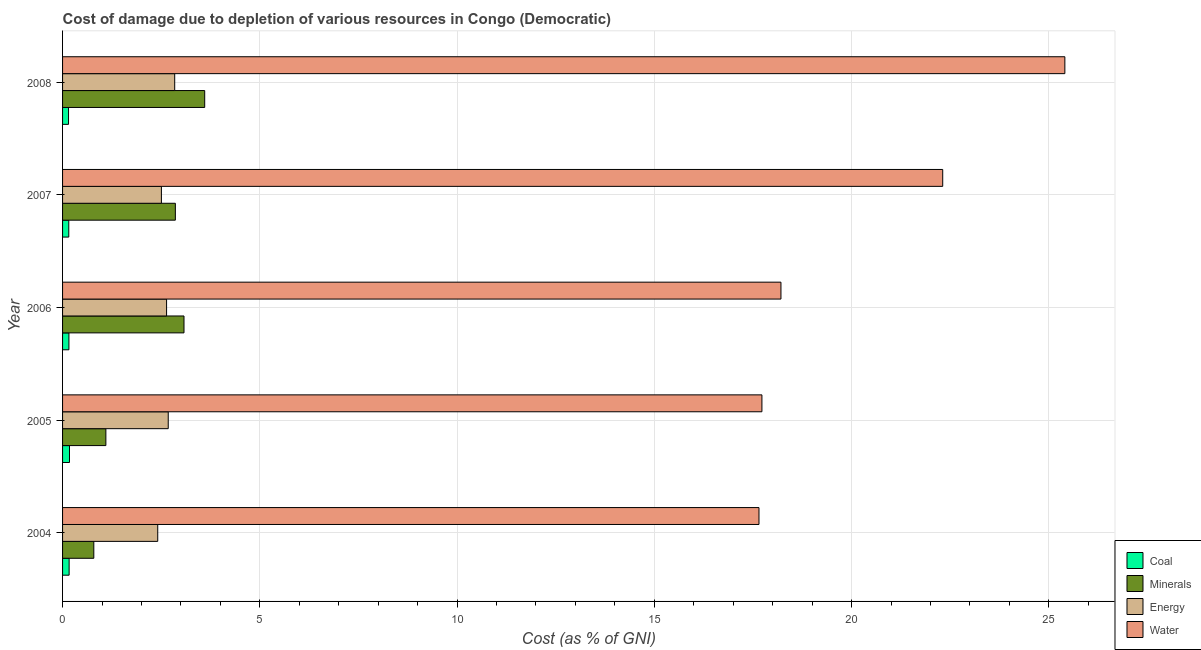Are the number of bars per tick equal to the number of legend labels?
Provide a short and direct response. Yes. How many bars are there on the 1st tick from the bottom?
Provide a short and direct response. 4. What is the cost of damage due to depletion of energy in 2006?
Make the answer very short. 2.64. Across all years, what is the maximum cost of damage due to depletion of water?
Your answer should be compact. 25.41. Across all years, what is the minimum cost of damage due to depletion of energy?
Your answer should be very brief. 2.41. In which year was the cost of damage due to depletion of water minimum?
Make the answer very short. 2004. What is the total cost of damage due to depletion of energy in the graph?
Your response must be concise. 13.08. What is the difference between the cost of damage due to depletion of energy in 2005 and that in 2007?
Give a very brief answer. 0.17. What is the difference between the cost of damage due to depletion of minerals in 2004 and the cost of damage due to depletion of coal in 2006?
Provide a short and direct response. 0.63. What is the average cost of damage due to depletion of coal per year?
Offer a very short reply. 0.16. In the year 2007, what is the difference between the cost of damage due to depletion of energy and cost of damage due to depletion of coal?
Provide a short and direct response. 2.35. In how many years, is the cost of damage due to depletion of minerals greater than 1 %?
Offer a terse response. 4. What is the ratio of the cost of damage due to depletion of energy in 2006 to that in 2008?
Ensure brevity in your answer.  0.93. Is the cost of damage due to depletion of minerals in 2006 less than that in 2008?
Offer a terse response. Yes. What is the difference between the highest and the second highest cost of damage due to depletion of minerals?
Your answer should be compact. 0.53. What is the difference between the highest and the lowest cost of damage due to depletion of coal?
Keep it short and to the point. 0.02. Is the sum of the cost of damage due to depletion of energy in 2005 and 2007 greater than the maximum cost of damage due to depletion of minerals across all years?
Offer a very short reply. Yes. Is it the case that in every year, the sum of the cost of damage due to depletion of water and cost of damage due to depletion of energy is greater than the sum of cost of damage due to depletion of minerals and cost of damage due to depletion of coal?
Your answer should be compact. Yes. What does the 1st bar from the top in 2004 represents?
Provide a short and direct response. Water. What does the 1st bar from the bottom in 2008 represents?
Offer a very short reply. Coal. Is it the case that in every year, the sum of the cost of damage due to depletion of coal and cost of damage due to depletion of minerals is greater than the cost of damage due to depletion of energy?
Offer a very short reply. No. Does the graph contain any zero values?
Keep it short and to the point. No. How many legend labels are there?
Provide a succinct answer. 4. What is the title of the graph?
Your response must be concise. Cost of damage due to depletion of various resources in Congo (Democratic) . What is the label or title of the X-axis?
Give a very brief answer. Cost (as % of GNI). What is the Cost (as % of GNI) in Coal in 2004?
Provide a succinct answer. 0.17. What is the Cost (as % of GNI) of Minerals in 2004?
Your response must be concise. 0.79. What is the Cost (as % of GNI) of Energy in 2004?
Provide a short and direct response. 2.41. What is the Cost (as % of GNI) of Water in 2004?
Offer a very short reply. 17.65. What is the Cost (as % of GNI) in Coal in 2005?
Ensure brevity in your answer.  0.18. What is the Cost (as % of GNI) of Minerals in 2005?
Provide a succinct answer. 1.1. What is the Cost (as % of GNI) of Energy in 2005?
Make the answer very short. 2.68. What is the Cost (as % of GNI) in Water in 2005?
Keep it short and to the point. 17.73. What is the Cost (as % of GNI) in Coal in 2006?
Ensure brevity in your answer.  0.16. What is the Cost (as % of GNI) in Minerals in 2006?
Your response must be concise. 3.08. What is the Cost (as % of GNI) in Energy in 2006?
Your answer should be very brief. 2.64. What is the Cost (as % of GNI) of Water in 2006?
Offer a very short reply. 18.21. What is the Cost (as % of GNI) in Coal in 2007?
Your response must be concise. 0.16. What is the Cost (as % of GNI) in Minerals in 2007?
Offer a terse response. 2.86. What is the Cost (as % of GNI) in Energy in 2007?
Offer a very short reply. 2.51. What is the Cost (as % of GNI) in Water in 2007?
Provide a succinct answer. 22.31. What is the Cost (as % of GNI) in Coal in 2008?
Offer a very short reply. 0.15. What is the Cost (as % of GNI) in Minerals in 2008?
Your answer should be very brief. 3.6. What is the Cost (as % of GNI) of Energy in 2008?
Your answer should be very brief. 2.84. What is the Cost (as % of GNI) in Water in 2008?
Ensure brevity in your answer.  25.41. Across all years, what is the maximum Cost (as % of GNI) in Coal?
Give a very brief answer. 0.18. Across all years, what is the maximum Cost (as % of GNI) of Minerals?
Provide a short and direct response. 3.6. Across all years, what is the maximum Cost (as % of GNI) of Energy?
Ensure brevity in your answer.  2.84. Across all years, what is the maximum Cost (as % of GNI) of Water?
Offer a very short reply. 25.41. Across all years, what is the minimum Cost (as % of GNI) in Coal?
Keep it short and to the point. 0.15. Across all years, what is the minimum Cost (as % of GNI) of Minerals?
Make the answer very short. 0.79. Across all years, what is the minimum Cost (as % of GNI) of Energy?
Keep it short and to the point. 2.41. Across all years, what is the minimum Cost (as % of GNI) of Water?
Keep it short and to the point. 17.65. What is the total Cost (as % of GNI) of Coal in the graph?
Offer a very short reply. 0.81. What is the total Cost (as % of GNI) of Minerals in the graph?
Provide a short and direct response. 11.43. What is the total Cost (as % of GNI) of Energy in the graph?
Your response must be concise. 13.08. What is the total Cost (as % of GNI) in Water in the graph?
Give a very brief answer. 101.31. What is the difference between the Cost (as % of GNI) in Coal in 2004 and that in 2005?
Your answer should be very brief. -0.01. What is the difference between the Cost (as % of GNI) of Minerals in 2004 and that in 2005?
Your answer should be compact. -0.31. What is the difference between the Cost (as % of GNI) of Energy in 2004 and that in 2005?
Keep it short and to the point. -0.27. What is the difference between the Cost (as % of GNI) in Water in 2004 and that in 2005?
Offer a terse response. -0.07. What is the difference between the Cost (as % of GNI) of Coal in 2004 and that in 2006?
Offer a very short reply. 0.01. What is the difference between the Cost (as % of GNI) in Minerals in 2004 and that in 2006?
Provide a succinct answer. -2.29. What is the difference between the Cost (as % of GNI) in Energy in 2004 and that in 2006?
Provide a succinct answer. -0.22. What is the difference between the Cost (as % of GNI) in Water in 2004 and that in 2006?
Your answer should be very brief. -0.56. What is the difference between the Cost (as % of GNI) of Coal in 2004 and that in 2007?
Give a very brief answer. 0.01. What is the difference between the Cost (as % of GNI) of Minerals in 2004 and that in 2007?
Make the answer very short. -2.07. What is the difference between the Cost (as % of GNI) in Energy in 2004 and that in 2007?
Ensure brevity in your answer.  -0.09. What is the difference between the Cost (as % of GNI) of Water in 2004 and that in 2007?
Ensure brevity in your answer.  -4.66. What is the difference between the Cost (as % of GNI) of Coal in 2004 and that in 2008?
Your answer should be very brief. 0.02. What is the difference between the Cost (as % of GNI) of Minerals in 2004 and that in 2008?
Provide a succinct answer. -2.81. What is the difference between the Cost (as % of GNI) of Energy in 2004 and that in 2008?
Provide a short and direct response. -0.43. What is the difference between the Cost (as % of GNI) of Water in 2004 and that in 2008?
Keep it short and to the point. -7.75. What is the difference between the Cost (as % of GNI) of Coal in 2005 and that in 2006?
Provide a succinct answer. 0.01. What is the difference between the Cost (as % of GNI) in Minerals in 2005 and that in 2006?
Offer a terse response. -1.98. What is the difference between the Cost (as % of GNI) in Energy in 2005 and that in 2006?
Ensure brevity in your answer.  0.04. What is the difference between the Cost (as % of GNI) in Water in 2005 and that in 2006?
Offer a very short reply. -0.48. What is the difference between the Cost (as % of GNI) in Coal in 2005 and that in 2007?
Offer a very short reply. 0.02. What is the difference between the Cost (as % of GNI) in Minerals in 2005 and that in 2007?
Your answer should be compact. -1.76. What is the difference between the Cost (as % of GNI) in Energy in 2005 and that in 2007?
Provide a succinct answer. 0.17. What is the difference between the Cost (as % of GNI) of Water in 2005 and that in 2007?
Offer a very short reply. -4.58. What is the difference between the Cost (as % of GNI) in Coal in 2005 and that in 2008?
Provide a short and direct response. 0.02. What is the difference between the Cost (as % of GNI) of Minerals in 2005 and that in 2008?
Your answer should be very brief. -2.51. What is the difference between the Cost (as % of GNI) of Energy in 2005 and that in 2008?
Your answer should be very brief. -0.16. What is the difference between the Cost (as % of GNI) of Water in 2005 and that in 2008?
Provide a short and direct response. -7.68. What is the difference between the Cost (as % of GNI) of Coal in 2006 and that in 2007?
Provide a short and direct response. 0. What is the difference between the Cost (as % of GNI) of Minerals in 2006 and that in 2007?
Your answer should be very brief. 0.22. What is the difference between the Cost (as % of GNI) of Energy in 2006 and that in 2007?
Provide a succinct answer. 0.13. What is the difference between the Cost (as % of GNI) in Water in 2006 and that in 2007?
Keep it short and to the point. -4.1. What is the difference between the Cost (as % of GNI) of Coal in 2006 and that in 2008?
Your response must be concise. 0.01. What is the difference between the Cost (as % of GNI) in Minerals in 2006 and that in 2008?
Offer a terse response. -0.53. What is the difference between the Cost (as % of GNI) of Energy in 2006 and that in 2008?
Your response must be concise. -0.21. What is the difference between the Cost (as % of GNI) in Water in 2006 and that in 2008?
Offer a very short reply. -7.2. What is the difference between the Cost (as % of GNI) in Coal in 2007 and that in 2008?
Offer a very short reply. 0.01. What is the difference between the Cost (as % of GNI) in Minerals in 2007 and that in 2008?
Ensure brevity in your answer.  -0.74. What is the difference between the Cost (as % of GNI) of Energy in 2007 and that in 2008?
Ensure brevity in your answer.  -0.34. What is the difference between the Cost (as % of GNI) of Water in 2007 and that in 2008?
Your answer should be compact. -3.1. What is the difference between the Cost (as % of GNI) in Coal in 2004 and the Cost (as % of GNI) in Minerals in 2005?
Make the answer very short. -0.93. What is the difference between the Cost (as % of GNI) of Coal in 2004 and the Cost (as % of GNI) of Energy in 2005?
Provide a succinct answer. -2.51. What is the difference between the Cost (as % of GNI) of Coal in 2004 and the Cost (as % of GNI) of Water in 2005?
Offer a terse response. -17.56. What is the difference between the Cost (as % of GNI) of Minerals in 2004 and the Cost (as % of GNI) of Energy in 2005?
Make the answer very short. -1.89. What is the difference between the Cost (as % of GNI) in Minerals in 2004 and the Cost (as % of GNI) in Water in 2005?
Offer a terse response. -16.94. What is the difference between the Cost (as % of GNI) in Energy in 2004 and the Cost (as % of GNI) in Water in 2005?
Your answer should be compact. -15.32. What is the difference between the Cost (as % of GNI) in Coal in 2004 and the Cost (as % of GNI) in Minerals in 2006?
Provide a succinct answer. -2.91. What is the difference between the Cost (as % of GNI) in Coal in 2004 and the Cost (as % of GNI) in Energy in 2006?
Provide a succinct answer. -2.47. What is the difference between the Cost (as % of GNI) of Coal in 2004 and the Cost (as % of GNI) of Water in 2006?
Your response must be concise. -18.04. What is the difference between the Cost (as % of GNI) in Minerals in 2004 and the Cost (as % of GNI) in Energy in 2006?
Your answer should be compact. -1.84. What is the difference between the Cost (as % of GNI) of Minerals in 2004 and the Cost (as % of GNI) of Water in 2006?
Your answer should be compact. -17.42. What is the difference between the Cost (as % of GNI) of Energy in 2004 and the Cost (as % of GNI) of Water in 2006?
Offer a very short reply. -15.8. What is the difference between the Cost (as % of GNI) of Coal in 2004 and the Cost (as % of GNI) of Minerals in 2007?
Ensure brevity in your answer.  -2.69. What is the difference between the Cost (as % of GNI) in Coal in 2004 and the Cost (as % of GNI) in Energy in 2007?
Offer a terse response. -2.34. What is the difference between the Cost (as % of GNI) in Coal in 2004 and the Cost (as % of GNI) in Water in 2007?
Give a very brief answer. -22.14. What is the difference between the Cost (as % of GNI) in Minerals in 2004 and the Cost (as % of GNI) in Energy in 2007?
Ensure brevity in your answer.  -1.71. What is the difference between the Cost (as % of GNI) of Minerals in 2004 and the Cost (as % of GNI) of Water in 2007?
Ensure brevity in your answer.  -21.52. What is the difference between the Cost (as % of GNI) of Energy in 2004 and the Cost (as % of GNI) of Water in 2007?
Your response must be concise. -19.9. What is the difference between the Cost (as % of GNI) in Coal in 2004 and the Cost (as % of GNI) in Minerals in 2008?
Offer a very short reply. -3.44. What is the difference between the Cost (as % of GNI) in Coal in 2004 and the Cost (as % of GNI) in Energy in 2008?
Your answer should be compact. -2.68. What is the difference between the Cost (as % of GNI) in Coal in 2004 and the Cost (as % of GNI) in Water in 2008?
Keep it short and to the point. -25.24. What is the difference between the Cost (as % of GNI) in Minerals in 2004 and the Cost (as % of GNI) in Energy in 2008?
Ensure brevity in your answer.  -2.05. What is the difference between the Cost (as % of GNI) in Minerals in 2004 and the Cost (as % of GNI) in Water in 2008?
Provide a succinct answer. -24.61. What is the difference between the Cost (as % of GNI) of Energy in 2004 and the Cost (as % of GNI) of Water in 2008?
Offer a terse response. -22.99. What is the difference between the Cost (as % of GNI) in Coal in 2005 and the Cost (as % of GNI) in Minerals in 2006?
Your answer should be very brief. -2.9. What is the difference between the Cost (as % of GNI) of Coal in 2005 and the Cost (as % of GNI) of Energy in 2006?
Provide a succinct answer. -2.46. What is the difference between the Cost (as % of GNI) in Coal in 2005 and the Cost (as % of GNI) in Water in 2006?
Your answer should be very brief. -18.03. What is the difference between the Cost (as % of GNI) in Minerals in 2005 and the Cost (as % of GNI) in Energy in 2006?
Make the answer very short. -1.54. What is the difference between the Cost (as % of GNI) in Minerals in 2005 and the Cost (as % of GNI) in Water in 2006?
Make the answer very short. -17.11. What is the difference between the Cost (as % of GNI) in Energy in 2005 and the Cost (as % of GNI) in Water in 2006?
Provide a short and direct response. -15.53. What is the difference between the Cost (as % of GNI) of Coal in 2005 and the Cost (as % of GNI) of Minerals in 2007?
Give a very brief answer. -2.68. What is the difference between the Cost (as % of GNI) in Coal in 2005 and the Cost (as % of GNI) in Energy in 2007?
Offer a terse response. -2.33. What is the difference between the Cost (as % of GNI) of Coal in 2005 and the Cost (as % of GNI) of Water in 2007?
Provide a short and direct response. -22.13. What is the difference between the Cost (as % of GNI) in Minerals in 2005 and the Cost (as % of GNI) in Energy in 2007?
Your answer should be very brief. -1.41. What is the difference between the Cost (as % of GNI) of Minerals in 2005 and the Cost (as % of GNI) of Water in 2007?
Ensure brevity in your answer.  -21.21. What is the difference between the Cost (as % of GNI) in Energy in 2005 and the Cost (as % of GNI) in Water in 2007?
Offer a very short reply. -19.63. What is the difference between the Cost (as % of GNI) in Coal in 2005 and the Cost (as % of GNI) in Minerals in 2008?
Keep it short and to the point. -3.43. What is the difference between the Cost (as % of GNI) of Coal in 2005 and the Cost (as % of GNI) of Energy in 2008?
Provide a short and direct response. -2.67. What is the difference between the Cost (as % of GNI) of Coal in 2005 and the Cost (as % of GNI) of Water in 2008?
Your response must be concise. -25.23. What is the difference between the Cost (as % of GNI) in Minerals in 2005 and the Cost (as % of GNI) in Energy in 2008?
Provide a short and direct response. -1.74. What is the difference between the Cost (as % of GNI) of Minerals in 2005 and the Cost (as % of GNI) of Water in 2008?
Your answer should be compact. -24.31. What is the difference between the Cost (as % of GNI) of Energy in 2005 and the Cost (as % of GNI) of Water in 2008?
Make the answer very short. -22.73. What is the difference between the Cost (as % of GNI) in Coal in 2006 and the Cost (as % of GNI) in Minerals in 2007?
Keep it short and to the point. -2.7. What is the difference between the Cost (as % of GNI) in Coal in 2006 and the Cost (as % of GNI) in Energy in 2007?
Provide a succinct answer. -2.34. What is the difference between the Cost (as % of GNI) in Coal in 2006 and the Cost (as % of GNI) in Water in 2007?
Give a very brief answer. -22.15. What is the difference between the Cost (as % of GNI) of Minerals in 2006 and the Cost (as % of GNI) of Energy in 2007?
Give a very brief answer. 0.57. What is the difference between the Cost (as % of GNI) of Minerals in 2006 and the Cost (as % of GNI) of Water in 2007?
Your answer should be compact. -19.23. What is the difference between the Cost (as % of GNI) in Energy in 2006 and the Cost (as % of GNI) in Water in 2007?
Your answer should be very brief. -19.67. What is the difference between the Cost (as % of GNI) of Coal in 2006 and the Cost (as % of GNI) of Minerals in 2008?
Make the answer very short. -3.44. What is the difference between the Cost (as % of GNI) in Coal in 2006 and the Cost (as % of GNI) in Energy in 2008?
Your answer should be compact. -2.68. What is the difference between the Cost (as % of GNI) of Coal in 2006 and the Cost (as % of GNI) of Water in 2008?
Provide a succinct answer. -25.25. What is the difference between the Cost (as % of GNI) in Minerals in 2006 and the Cost (as % of GNI) in Energy in 2008?
Keep it short and to the point. 0.24. What is the difference between the Cost (as % of GNI) in Minerals in 2006 and the Cost (as % of GNI) in Water in 2008?
Offer a very short reply. -22.33. What is the difference between the Cost (as % of GNI) in Energy in 2006 and the Cost (as % of GNI) in Water in 2008?
Offer a terse response. -22.77. What is the difference between the Cost (as % of GNI) in Coal in 2007 and the Cost (as % of GNI) in Minerals in 2008?
Provide a succinct answer. -3.45. What is the difference between the Cost (as % of GNI) of Coal in 2007 and the Cost (as % of GNI) of Energy in 2008?
Provide a succinct answer. -2.68. What is the difference between the Cost (as % of GNI) of Coal in 2007 and the Cost (as % of GNI) of Water in 2008?
Ensure brevity in your answer.  -25.25. What is the difference between the Cost (as % of GNI) in Minerals in 2007 and the Cost (as % of GNI) in Energy in 2008?
Your response must be concise. 0.02. What is the difference between the Cost (as % of GNI) of Minerals in 2007 and the Cost (as % of GNI) of Water in 2008?
Ensure brevity in your answer.  -22.55. What is the difference between the Cost (as % of GNI) of Energy in 2007 and the Cost (as % of GNI) of Water in 2008?
Your response must be concise. -22.9. What is the average Cost (as % of GNI) in Coal per year?
Provide a succinct answer. 0.16. What is the average Cost (as % of GNI) of Minerals per year?
Keep it short and to the point. 2.29. What is the average Cost (as % of GNI) of Energy per year?
Keep it short and to the point. 2.62. What is the average Cost (as % of GNI) of Water per year?
Your answer should be very brief. 20.26. In the year 2004, what is the difference between the Cost (as % of GNI) in Coal and Cost (as % of GNI) in Minerals?
Provide a succinct answer. -0.63. In the year 2004, what is the difference between the Cost (as % of GNI) in Coal and Cost (as % of GNI) in Energy?
Give a very brief answer. -2.25. In the year 2004, what is the difference between the Cost (as % of GNI) of Coal and Cost (as % of GNI) of Water?
Your response must be concise. -17.49. In the year 2004, what is the difference between the Cost (as % of GNI) of Minerals and Cost (as % of GNI) of Energy?
Ensure brevity in your answer.  -1.62. In the year 2004, what is the difference between the Cost (as % of GNI) in Minerals and Cost (as % of GNI) in Water?
Ensure brevity in your answer.  -16.86. In the year 2004, what is the difference between the Cost (as % of GNI) of Energy and Cost (as % of GNI) of Water?
Offer a very short reply. -15.24. In the year 2005, what is the difference between the Cost (as % of GNI) of Coal and Cost (as % of GNI) of Minerals?
Your answer should be very brief. -0.92. In the year 2005, what is the difference between the Cost (as % of GNI) of Coal and Cost (as % of GNI) of Energy?
Your response must be concise. -2.5. In the year 2005, what is the difference between the Cost (as % of GNI) in Coal and Cost (as % of GNI) in Water?
Ensure brevity in your answer.  -17.55. In the year 2005, what is the difference between the Cost (as % of GNI) in Minerals and Cost (as % of GNI) in Energy?
Ensure brevity in your answer.  -1.58. In the year 2005, what is the difference between the Cost (as % of GNI) of Minerals and Cost (as % of GNI) of Water?
Make the answer very short. -16.63. In the year 2005, what is the difference between the Cost (as % of GNI) of Energy and Cost (as % of GNI) of Water?
Make the answer very short. -15.05. In the year 2006, what is the difference between the Cost (as % of GNI) of Coal and Cost (as % of GNI) of Minerals?
Your answer should be very brief. -2.92. In the year 2006, what is the difference between the Cost (as % of GNI) in Coal and Cost (as % of GNI) in Energy?
Your answer should be compact. -2.48. In the year 2006, what is the difference between the Cost (as % of GNI) in Coal and Cost (as % of GNI) in Water?
Give a very brief answer. -18.05. In the year 2006, what is the difference between the Cost (as % of GNI) in Minerals and Cost (as % of GNI) in Energy?
Provide a short and direct response. 0.44. In the year 2006, what is the difference between the Cost (as % of GNI) in Minerals and Cost (as % of GNI) in Water?
Give a very brief answer. -15.13. In the year 2006, what is the difference between the Cost (as % of GNI) of Energy and Cost (as % of GNI) of Water?
Keep it short and to the point. -15.57. In the year 2007, what is the difference between the Cost (as % of GNI) of Coal and Cost (as % of GNI) of Minerals?
Provide a succinct answer. -2.7. In the year 2007, what is the difference between the Cost (as % of GNI) of Coal and Cost (as % of GNI) of Energy?
Make the answer very short. -2.35. In the year 2007, what is the difference between the Cost (as % of GNI) in Coal and Cost (as % of GNI) in Water?
Your answer should be very brief. -22.15. In the year 2007, what is the difference between the Cost (as % of GNI) of Minerals and Cost (as % of GNI) of Energy?
Make the answer very short. 0.35. In the year 2007, what is the difference between the Cost (as % of GNI) in Minerals and Cost (as % of GNI) in Water?
Provide a succinct answer. -19.45. In the year 2007, what is the difference between the Cost (as % of GNI) in Energy and Cost (as % of GNI) in Water?
Your answer should be very brief. -19.81. In the year 2008, what is the difference between the Cost (as % of GNI) of Coal and Cost (as % of GNI) of Minerals?
Your answer should be compact. -3.45. In the year 2008, what is the difference between the Cost (as % of GNI) in Coal and Cost (as % of GNI) in Energy?
Make the answer very short. -2.69. In the year 2008, what is the difference between the Cost (as % of GNI) of Coal and Cost (as % of GNI) of Water?
Keep it short and to the point. -25.26. In the year 2008, what is the difference between the Cost (as % of GNI) of Minerals and Cost (as % of GNI) of Energy?
Provide a succinct answer. 0.76. In the year 2008, what is the difference between the Cost (as % of GNI) in Minerals and Cost (as % of GNI) in Water?
Offer a terse response. -21.8. In the year 2008, what is the difference between the Cost (as % of GNI) in Energy and Cost (as % of GNI) in Water?
Your answer should be very brief. -22.56. What is the ratio of the Cost (as % of GNI) of Coal in 2004 to that in 2005?
Keep it short and to the point. 0.94. What is the ratio of the Cost (as % of GNI) of Minerals in 2004 to that in 2005?
Give a very brief answer. 0.72. What is the ratio of the Cost (as % of GNI) of Energy in 2004 to that in 2005?
Give a very brief answer. 0.9. What is the ratio of the Cost (as % of GNI) of Coal in 2004 to that in 2006?
Offer a very short reply. 1.03. What is the ratio of the Cost (as % of GNI) of Minerals in 2004 to that in 2006?
Keep it short and to the point. 0.26. What is the ratio of the Cost (as % of GNI) of Energy in 2004 to that in 2006?
Offer a terse response. 0.91. What is the ratio of the Cost (as % of GNI) of Water in 2004 to that in 2006?
Give a very brief answer. 0.97. What is the ratio of the Cost (as % of GNI) in Coal in 2004 to that in 2007?
Give a very brief answer. 1.05. What is the ratio of the Cost (as % of GNI) of Minerals in 2004 to that in 2007?
Your response must be concise. 0.28. What is the ratio of the Cost (as % of GNI) of Energy in 2004 to that in 2007?
Your response must be concise. 0.96. What is the ratio of the Cost (as % of GNI) in Water in 2004 to that in 2007?
Your answer should be compact. 0.79. What is the ratio of the Cost (as % of GNI) of Coal in 2004 to that in 2008?
Ensure brevity in your answer.  1.1. What is the ratio of the Cost (as % of GNI) in Minerals in 2004 to that in 2008?
Ensure brevity in your answer.  0.22. What is the ratio of the Cost (as % of GNI) in Energy in 2004 to that in 2008?
Provide a short and direct response. 0.85. What is the ratio of the Cost (as % of GNI) of Water in 2004 to that in 2008?
Give a very brief answer. 0.69. What is the ratio of the Cost (as % of GNI) in Coal in 2005 to that in 2006?
Keep it short and to the point. 1.09. What is the ratio of the Cost (as % of GNI) of Minerals in 2005 to that in 2006?
Make the answer very short. 0.36. What is the ratio of the Cost (as % of GNI) of Energy in 2005 to that in 2006?
Keep it short and to the point. 1.02. What is the ratio of the Cost (as % of GNI) of Water in 2005 to that in 2006?
Ensure brevity in your answer.  0.97. What is the ratio of the Cost (as % of GNI) in Coal in 2005 to that in 2007?
Offer a terse response. 1.12. What is the ratio of the Cost (as % of GNI) of Minerals in 2005 to that in 2007?
Your answer should be very brief. 0.38. What is the ratio of the Cost (as % of GNI) in Energy in 2005 to that in 2007?
Your answer should be compact. 1.07. What is the ratio of the Cost (as % of GNI) in Water in 2005 to that in 2007?
Your answer should be very brief. 0.79. What is the ratio of the Cost (as % of GNI) of Coal in 2005 to that in 2008?
Make the answer very short. 1.16. What is the ratio of the Cost (as % of GNI) in Minerals in 2005 to that in 2008?
Offer a very short reply. 0.3. What is the ratio of the Cost (as % of GNI) in Energy in 2005 to that in 2008?
Your answer should be compact. 0.94. What is the ratio of the Cost (as % of GNI) in Water in 2005 to that in 2008?
Provide a short and direct response. 0.7. What is the ratio of the Cost (as % of GNI) of Coal in 2006 to that in 2007?
Your answer should be compact. 1.02. What is the ratio of the Cost (as % of GNI) in Minerals in 2006 to that in 2007?
Your answer should be compact. 1.08. What is the ratio of the Cost (as % of GNI) of Energy in 2006 to that in 2007?
Provide a short and direct response. 1.05. What is the ratio of the Cost (as % of GNI) in Water in 2006 to that in 2007?
Provide a short and direct response. 0.82. What is the ratio of the Cost (as % of GNI) in Coal in 2006 to that in 2008?
Keep it short and to the point. 1.07. What is the ratio of the Cost (as % of GNI) in Minerals in 2006 to that in 2008?
Ensure brevity in your answer.  0.85. What is the ratio of the Cost (as % of GNI) in Energy in 2006 to that in 2008?
Make the answer very short. 0.93. What is the ratio of the Cost (as % of GNI) of Water in 2006 to that in 2008?
Your response must be concise. 0.72. What is the ratio of the Cost (as % of GNI) in Coal in 2007 to that in 2008?
Your answer should be compact. 1.04. What is the ratio of the Cost (as % of GNI) of Minerals in 2007 to that in 2008?
Provide a succinct answer. 0.79. What is the ratio of the Cost (as % of GNI) of Energy in 2007 to that in 2008?
Provide a short and direct response. 0.88. What is the ratio of the Cost (as % of GNI) of Water in 2007 to that in 2008?
Your response must be concise. 0.88. What is the difference between the highest and the second highest Cost (as % of GNI) in Coal?
Your response must be concise. 0.01. What is the difference between the highest and the second highest Cost (as % of GNI) of Minerals?
Provide a succinct answer. 0.53. What is the difference between the highest and the second highest Cost (as % of GNI) in Energy?
Keep it short and to the point. 0.16. What is the difference between the highest and the second highest Cost (as % of GNI) in Water?
Offer a terse response. 3.1. What is the difference between the highest and the lowest Cost (as % of GNI) in Coal?
Provide a short and direct response. 0.02. What is the difference between the highest and the lowest Cost (as % of GNI) in Minerals?
Provide a short and direct response. 2.81. What is the difference between the highest and the lowest Cost (as % of GNI) in Energy?
Give a very brief answer. 0.43. What is the difference between the highest and the lowest Cost (as % of GNI) in Water?
Your answer should be very brief. 7.75. 